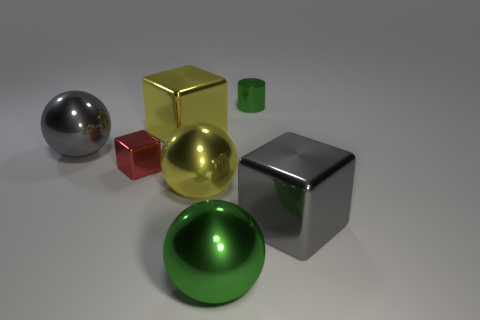Subtract all large yellow metallic spheres. How many spheres are left? 2 Subtract 1 cubes. How many cubes are left? 2 Subtract all gray spheres. How many spheres are left? 2 Subtract all spheres. How many objects are left? 4 Add 2 green objects. How many green objects exist? 4 Add 2 red metal blocks. How many objects exist? 9 Subtract 0 brown spheres. How many objects are left? 7 Subtract all cyan cylinders. Subtract all gray balls. How many cylinders are left? 1 Subtract all purple blocks. How many green balls are left? 1 Subtract all brown rubber cylinders. Subtract all gray things. How many objects are left? 5 